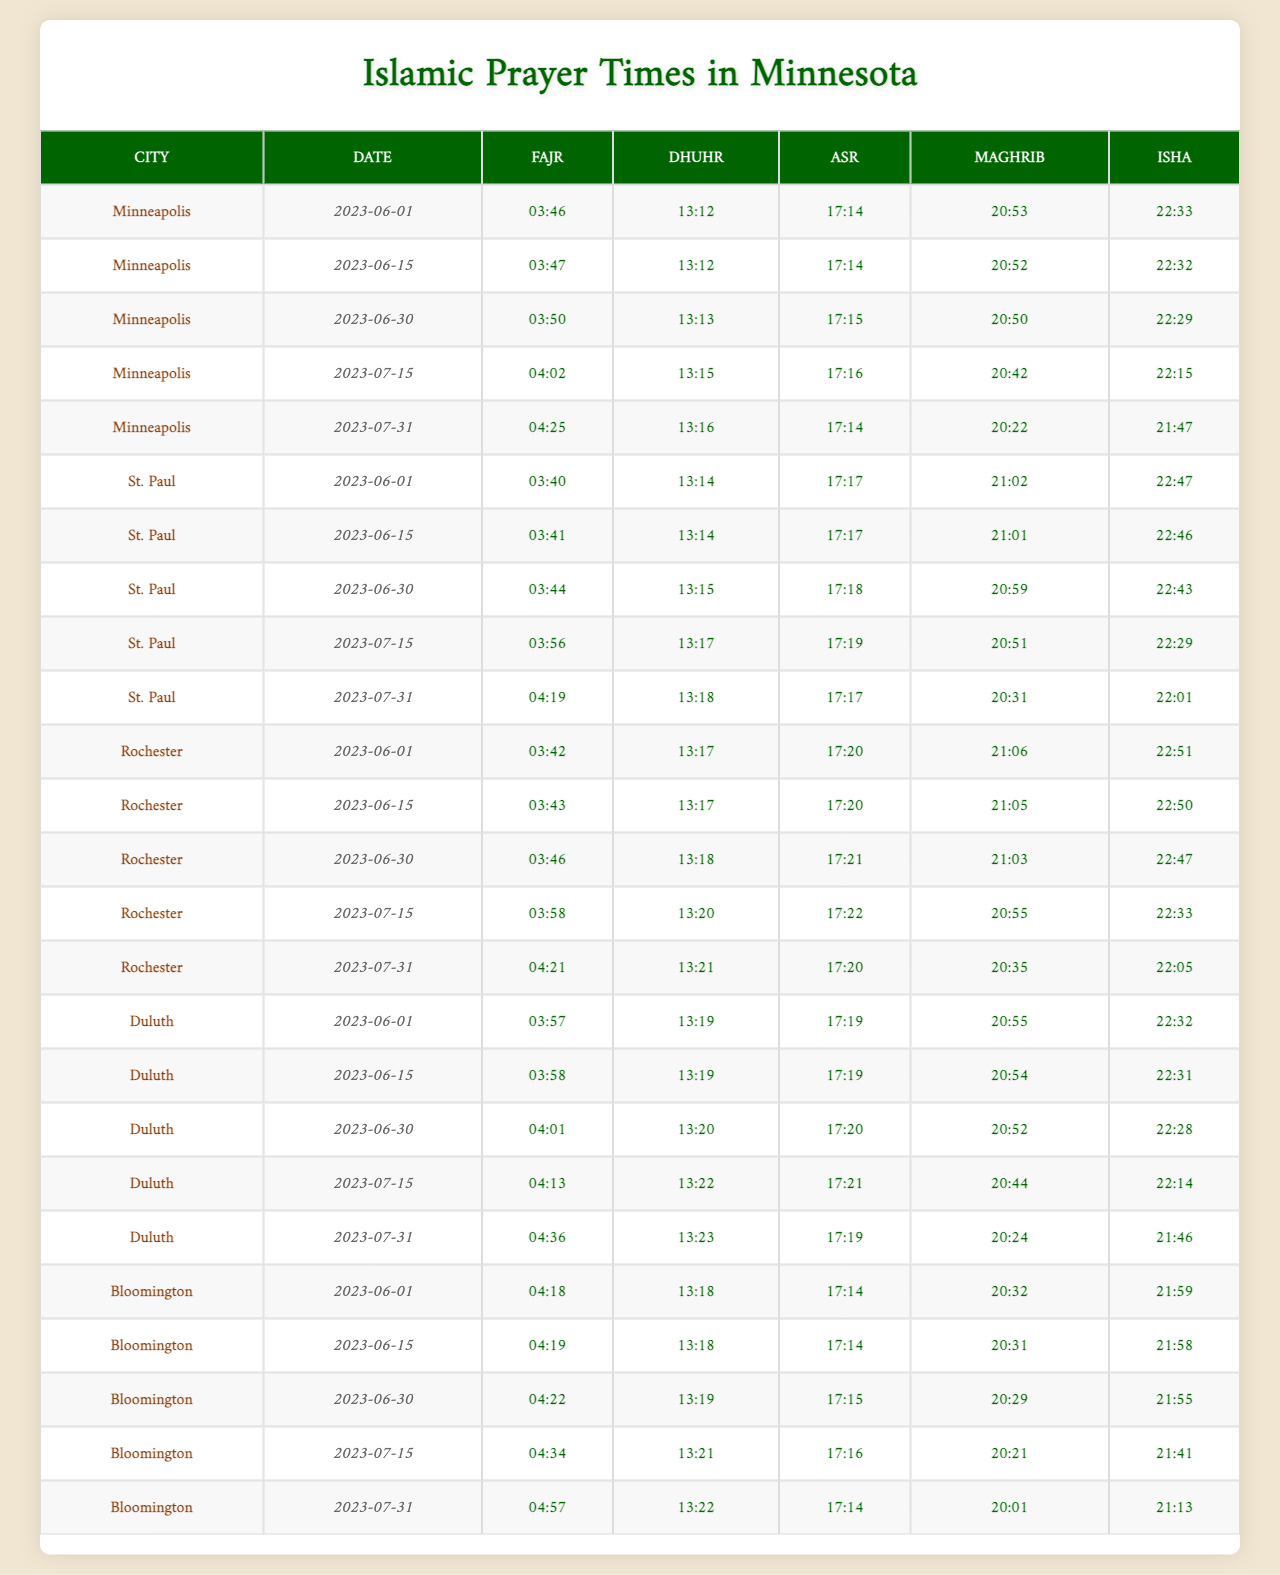What are the Fajr prayer times in Minneapolis for June 1, 2023? The Fajr prayer time for Minneapolis on June 1, 2023, is listed in the table. I find the corresponding row for Minneapolis and the date June 1, which shows the time as "03:46".
Answer: 03:46 What is the Dhuhr prayer time for St. Paul on June 15, 2023? By referring to the St. Paul row and June 15 column in the table, I can directly see that the Dhuhr prayer time is "13:14".
Answer: 13:14 How many minutes is there between the Asr prayer time on June 30 and July 15 in Rochester? First, I look up the Asr prayer times for Rochester on both dates. On June 30, it's "17:15", and on July 15, it's "17:20". The difference in minutes is (17:20 - 17:15) = 5 minutes.
Answer: 5 minutes Which city has the latest Maghrib prayer time on July 31, 2023? I check the Maghrib times for all the cities on July 31, 2023, and find: Minneapolis "20:32", St. Paul "20:31", Rochester "20:35", Duluth "20:24", and Bloomington "20:01". The latest time is in Rochester at "20:35".
Answer: Rochester Is the Isha prayer time in Duluth on June 30 earlier than the Isha time in Bloomington on June 15? I find both Isha times: Duluth on June 30 is "22:28" and Bloomington on June 15 is "22:01". Since "22:28" is later than "22:01", the answer to the question is no.
Answer: No What is the average Fajr prayer time for all cities on June 1? I will first convert the Fajr times into minutes after midnight: Minneapolis "03:46" (226), St. Paul "03:47" (227), Rochester "03:50" (230), Duluth "04:02" (242), and Bloomington "04:25" (265). I calculate the average as (226 + 227 + 230 + 242 + 265) / 5 = 238. The corresponding time in hours and minutes is "03:58".
Answer: 03:58 On which date does the Isha prayer time in St. Paul show the greatest increase compared to the previous date? I need to compare Isha prayer times for consecutive dates in St. Paul. The times are: June 1 "22:32", June 15 "22:46", June 30 "22:50", July 15 "22:31", and July 31 "22:01". The largest increase is from June 1 to June 15, with a difference of 14 minutes.
Answer: June 15 What is the difference in Dhuhr times between Minneapolis on June 15 and St. Paul on June 30? I check the Dhuhr prayer times: Minneapolis on June 15 is "13:14" and St. Paul on June 30 is "13:20". The difference is (13:20 - 13:14) = 6 minutes.
Answer: 6 minutes Which prayer is consistently the latest across all cities for July 15? By checking the table for the July 15 row, I find: Fajr times range from "04:01" to "04:36", Dhuhr from "13:19" to "13:23", Asr from "17:19" to "17:20", Maghrib from "20:24" to "20:55", and Isha from "21:46" to "22:32". The latest prayer consistently is Maghrib, with the latest time being "20:55" in Duluth.
Answer: Maghrib 